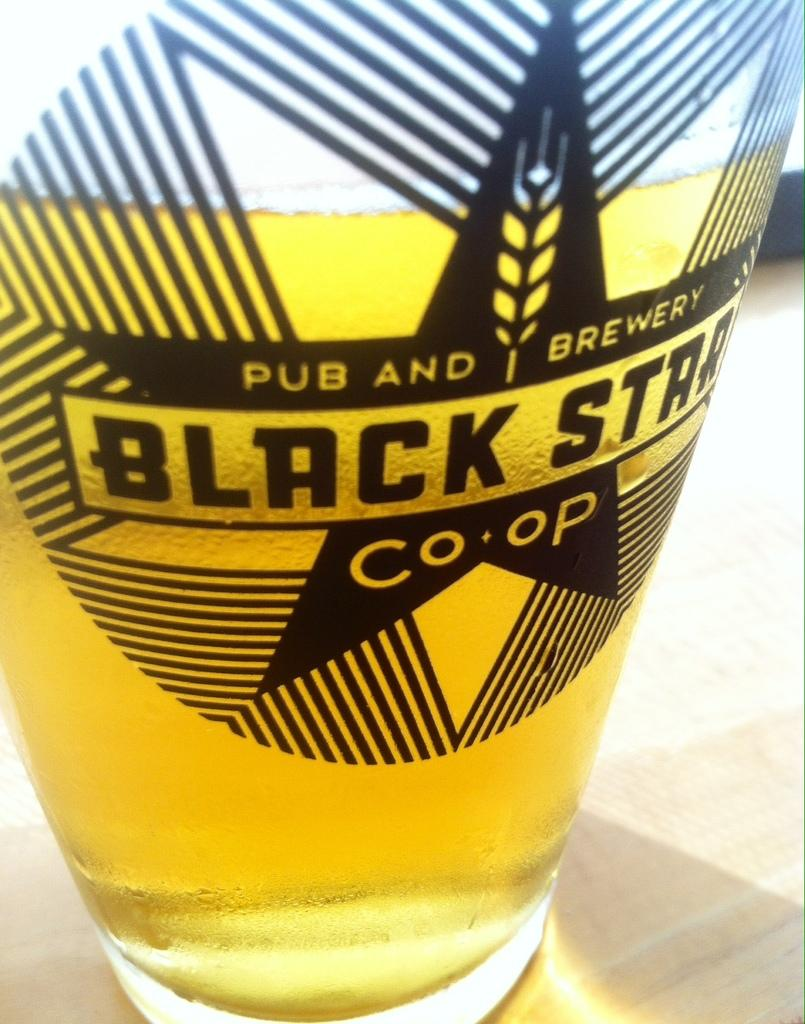<image>
Write a terse but informative summary of the picture. A glass of beer has a Black Star label on it. 